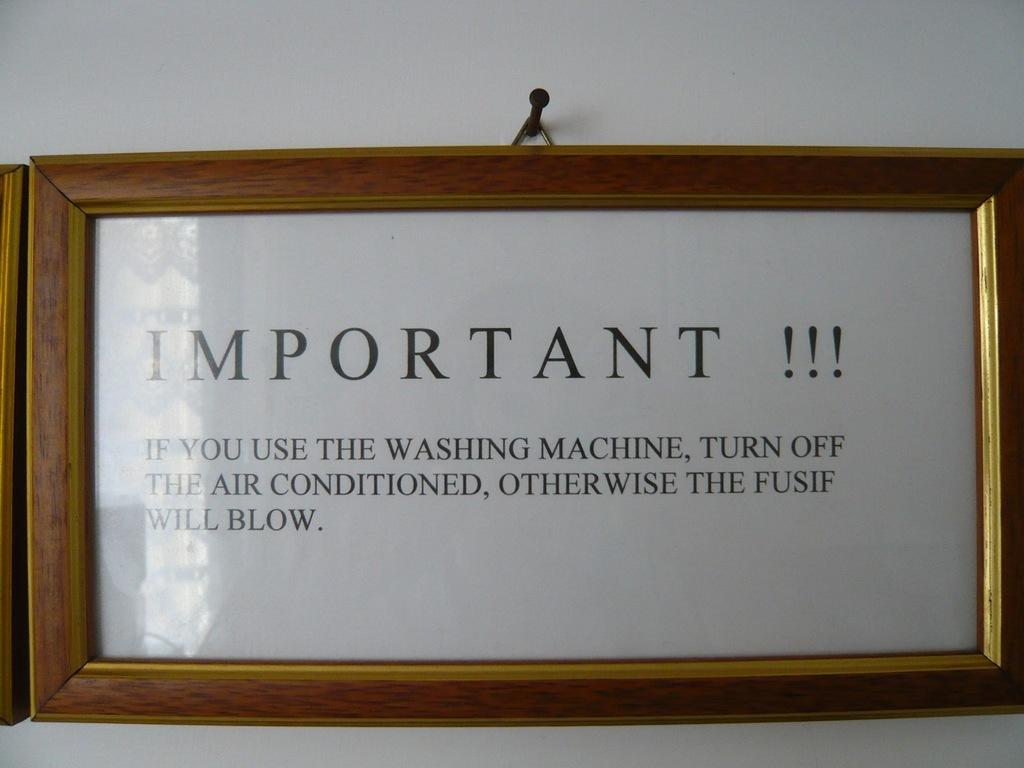<image>
Write a terse but informative summary of the picture. A sign advises washing machine and air conditioner users about potential power problems. 